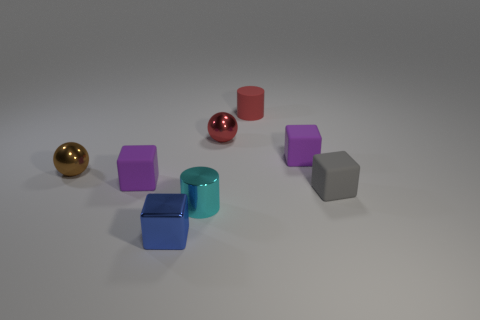There is a tiny metallic object that is the same color as the matte cylinder; what is its shape?
Offer a very short reply. Sphere. There is a cylinder in front of the tiny matte cylinder; is it the same color as the metallic cube?
Give a very brief answer. No. What number of red shiny spheres are the same size as the brown shiny ball?
Make the answer very short. 1. What is the shape of the cyan object that is the same material as the blue cube?
Offer a terse response. Cylinder. Are there any big things that have the same color as the metallic cylinder?
Provide a short and direct response. No. What is the small red sphere made of?
Provide a short and direct response. Metal. What number of things are yellow rubber balls or small gray cubes?
Provide a short and direct response. 1. There is a red cylinder on the right side of the brown metal thing; what is its size?
Keep it short and to the point. Small. How many other objects are the same material as the red cylinder?
Keep it short and to the point. 3. There is a red rubber cylinder that is behind the cyan metal cylinder; are there any red shiny spheres right of it?
Offer a very short reply. No. 